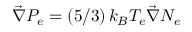Convert formula to latex. <formula><loc_0><loc_0><loc_500><loc_500>\vec { \nabla } P _ { e } = \left ( 5 / 3 \right ) k _ { B } T _ { e } \vec { \nabla } N _ { e }</formula> 